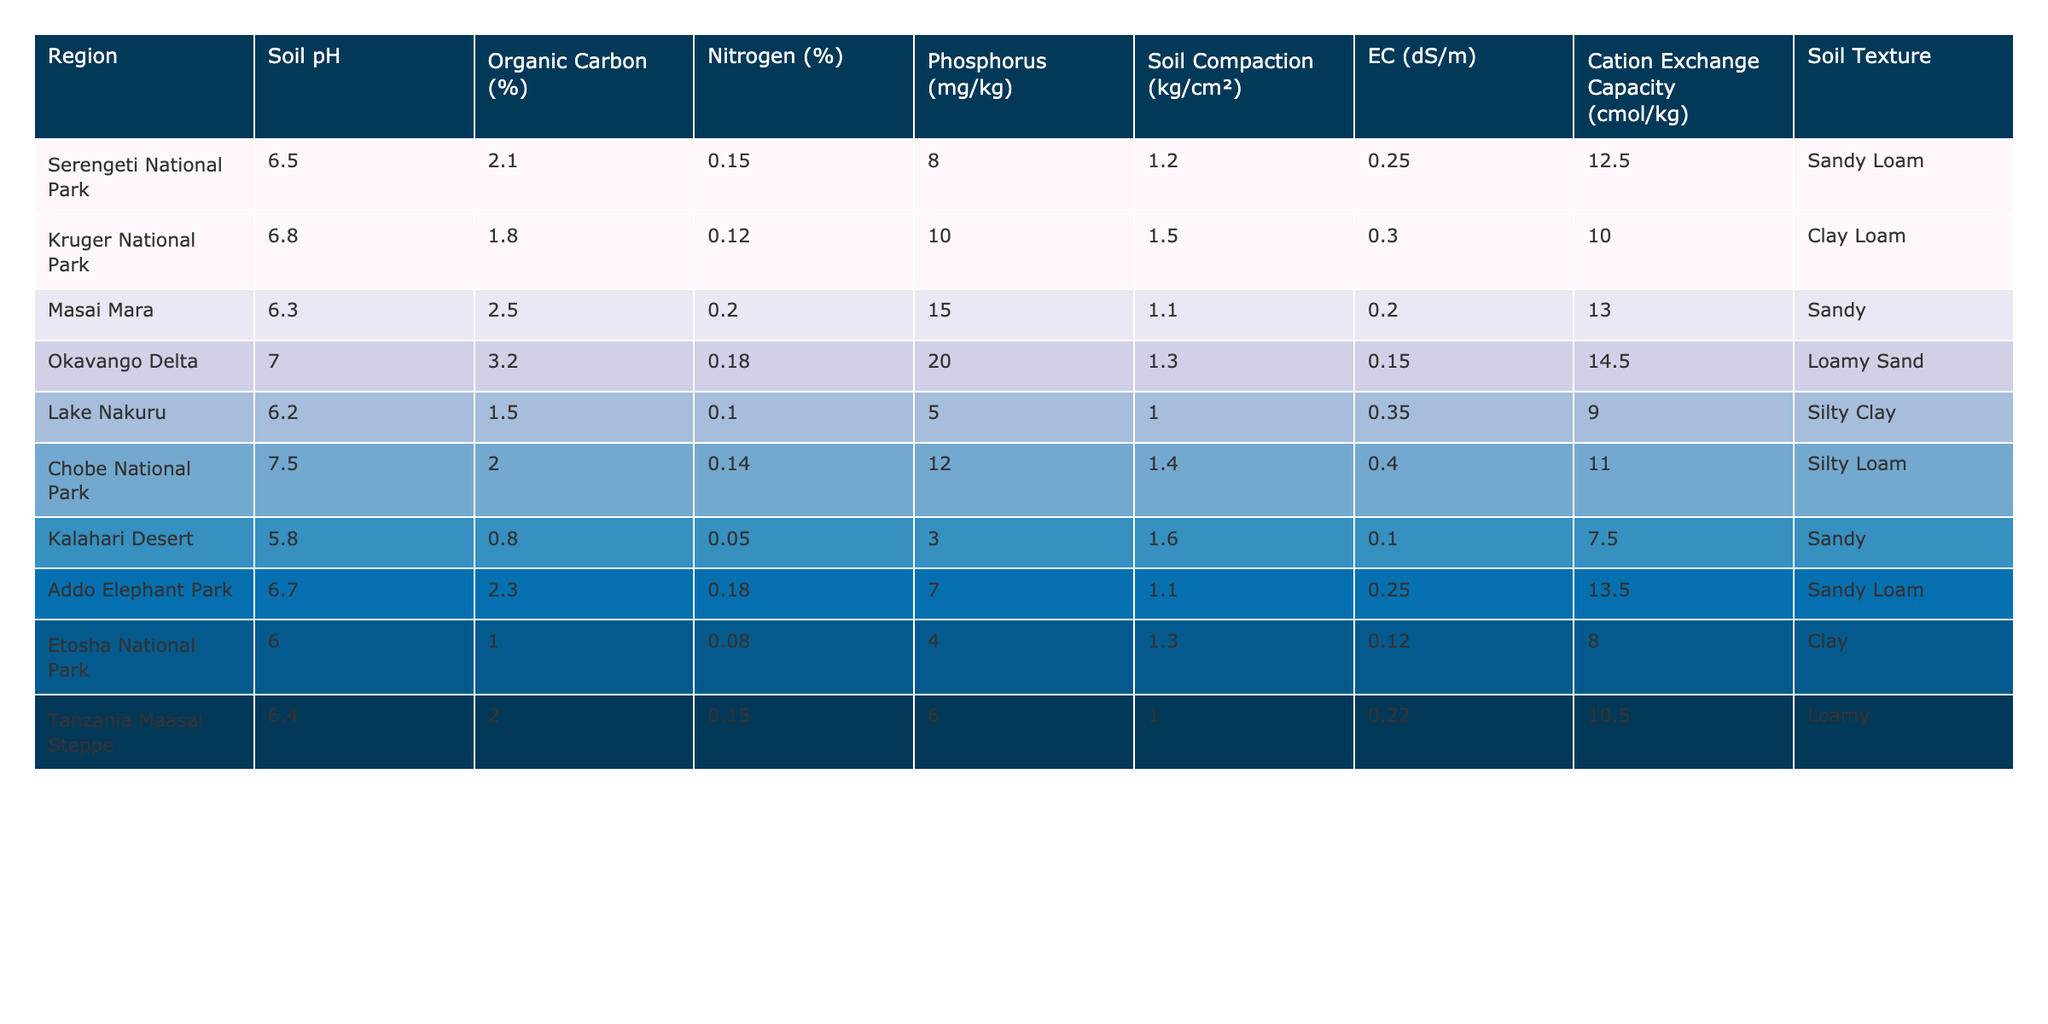What is the soil pH of Kruger National Park? The table provides the soil pH values for different regions. Looking at the row for Kruger National Park, the soil pH is listed as 6.8.
Answer: 6.8 Which region has the highest organic carbon percentage? By comparing the organic carbon percentages across all regions, Okavango Delta shows the highest value at 3.2%.
Answer: 3.2% What is the average nitrogen percentage across the seven regions? The nitrogen percentages are: 0.15, 0.12, 0.20, 0.18, 0.10, 0.14, 0.05, 0.18, and 0.15. Adding these gives a total of 1.12% and dividing by 7 results in an average of approximately 0.16%.
Answer: 0.16% Is the soil compaction in Addo Elephant Park greater than that of Lake Nakuru? The table shows that Addo Elephant Park has a soil compaction of 1.1 kg/cm², while Lake Nakuru has a compaction of 1.0 kg/cm². Since 1.1 is greater than 1.0, the statement is true.
Answer: Yes Which region has the lowest phosphorus content and what is that value? The lowest phosphorus content is shown in the region of Kalahari Desert, which has a phosphorus level of 3 mg/kg.
Answer: 3 mg/kg Is the cation exchange capacity greater in Masai Mara than in Serengeti National Park? The cation exchange capacities are 13.0 cmol/kg for Masai Mara and 12.5 cmol/kg for Serengeti National Park. Since 13.0 is greater than 12.5, the statement is true.
Answer: Yes What is the difference in soil pH between Okavango Delta and Kalahari Desert? The soil pH for Okavango Delta is 7.0 and for Kalahari Desert it is 5.8. The difference is calculated as 7.0 - 5.8 = 1.2.
Answer: 1.2 Which region has the highest electrical conductivity and what is that value? Referring to the table, Chobe National Park has the highest electrical conductivity at 0.40 dS/m.
Answer: 0.40 dS/m Which two regions have the same soil texture of Sandy Loam? The table indicates that both Serengeti National Park and Addo Elephant Park have a soil texture categorized as Sandy Loam.
Answer: Serengeti National Park and Addo Elephant Park What is the median value of organic carbon percentages across all regions? The organic carbon percentages, after sorting: 0.8, 1.0, 1.5, 1.8, 2.1, 2.3, 2.5, 3.2. Since there are 10 values, the median will be the average of the 5th and 6th (2.1 and 2.3), which is (2.1 + 2.3)/2 = 2.2%.
Answer: 2.2% 